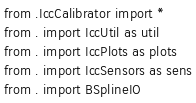Convert code to text. <code><loc_0><loc_0><loc_500><loc_500><_Python_>from .IccCalibrator import *
from . import IccUtil as util
from . import IccPlots as plots
from . import IccSensors as sens
from . import BSplineIO</code> 